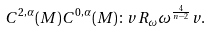Convert formula to latex. <formula><loc_0><loc_0><loc_500><loc_500>C ^ { 2 , \alpha } ( M ) C ^ { 0 , \alpha } ( M ) \colon v R _ { \omega } \omega ^ { \frac { 4 } { n - 2 } } v .</formula> 